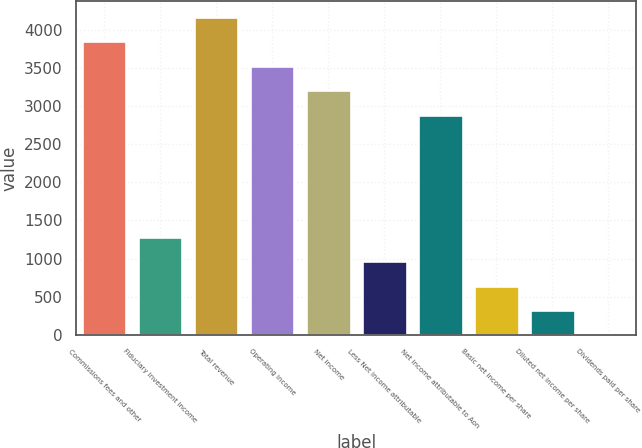<chart> <loc_0><loc_0><loc_500><loc_500><bar_chart><fcel>Commissions fees and other<fcel>Fiduciary investment income<fcel>Total revenue<fcel>Operating income<fcel>Net income<fcel>Less Net income attributable<fcel>Net income attributable to Aon<fcel>Basic net income per share<fcel>Diluted net income per share<fcel>Dividends paid per share<nl><fcel>3850.74<fcel>1283.7<fcel>4171.62<fcel>3529.86<fcel>3208.98<fcel>962.82<fcel>2888.1<fcel>641.94<fcel>321.06<fcel>0.18<nl></chart> 